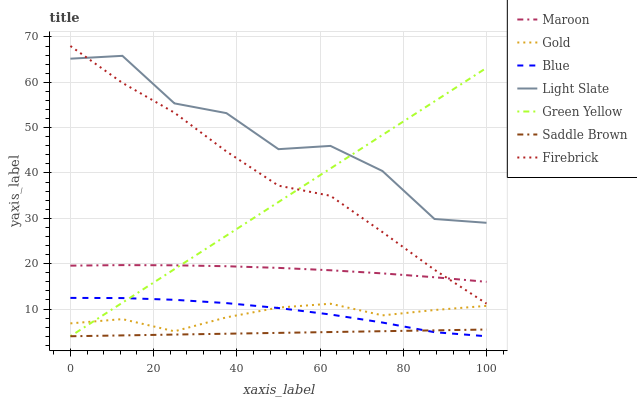Does Saddle Brown have the minimum area under the curve?
Answer yes or no. Yes. Does Light Slate have the maximum area under the curve?
Answer yes or no. Yes. Does Gold have the minimum area under the curve?
Answer yes or no. No. Does Gold have the maximum area under the curve?
Answer yes or no. No. Is Saddle Brown the smoothest?
Answer yes or no. Yes. Is Light Slate the roughest?
Answer yes or no. Yes. Is Gold the smoothest?
Answer yes or no. No. Is Gold the roughest?
Answer yes or no. No. Does Blue have the lowest value?
Answer yes or no. Yes. Does Gold have the lowest value?
Answer yes or no. No. Does Firebrick have the highest value?
Answer yes or no. Yes. Does Gold have the highest value?
Answer yes or no. No. Is Maroon less than Light Slate?
Answer yes or no. Yes. Is Maroon greater than Blue?
Answer yes or no. Yes. Does Blue intersect Green Yellow?
Answer yes or no. Yes. Is Blue less than Green Yellow?
Answer yes or no. No. Is Blue greater than Green Yellow?
Answer yes or no. No. Does Maroon intersect Light Slate?
Answer yes or no. No. 